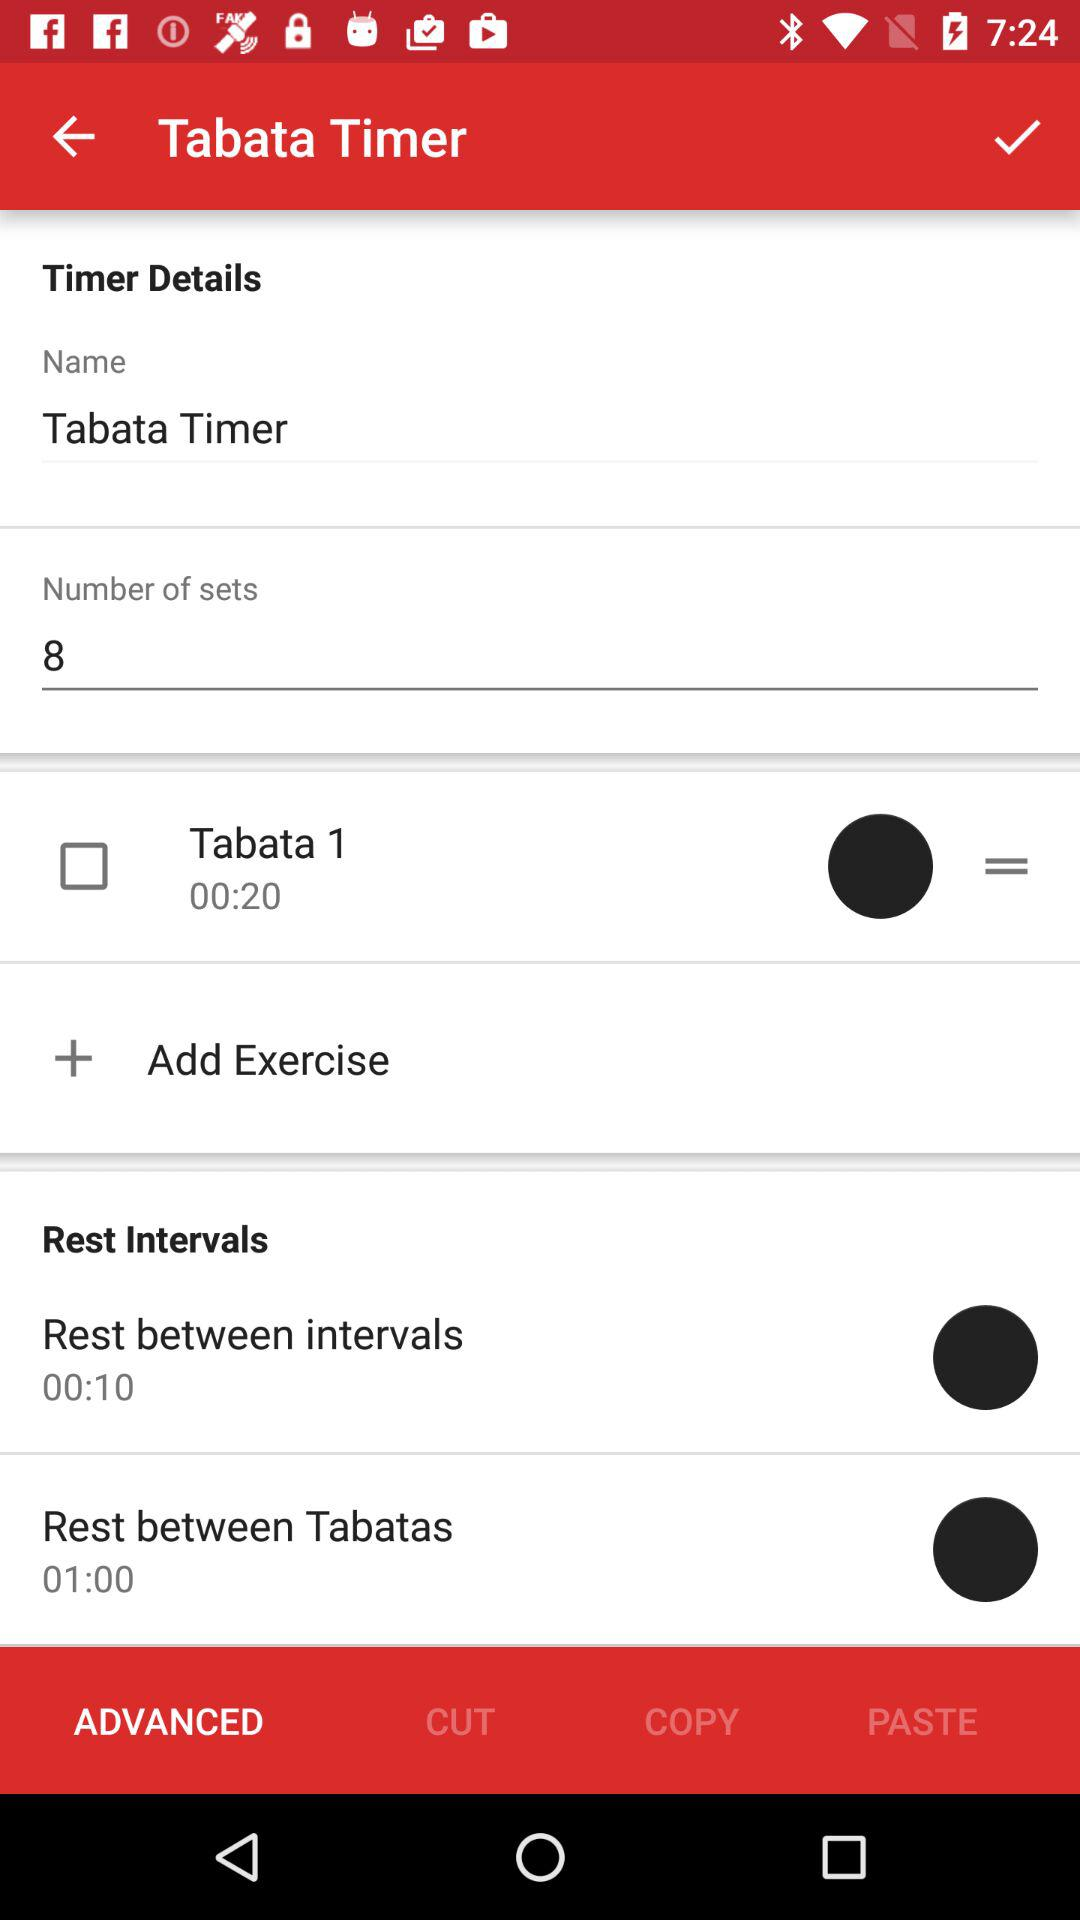What is the given duration in "Rest between Tabatas"? The given duration in "Rest between Tabatas" is 1 minute. 